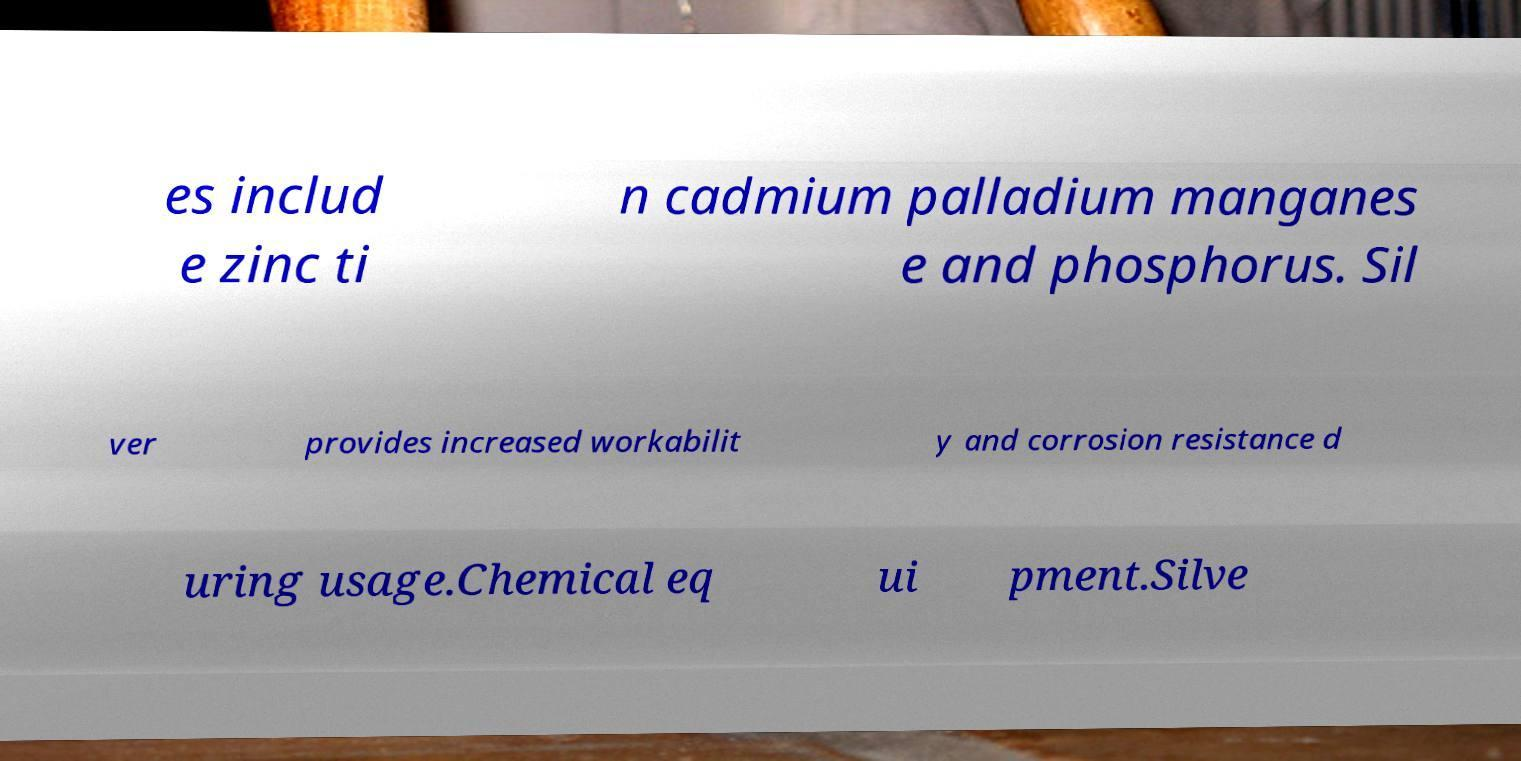What messages or text are displayed in this image? I need them in a readable, typed format. es includ e zinc ti n cadmium palladium manganes e and phosphorus. Sil ver provides increased workabilit y and corrosion resistance d uring usage.Chemical eq ui pment.Silve 